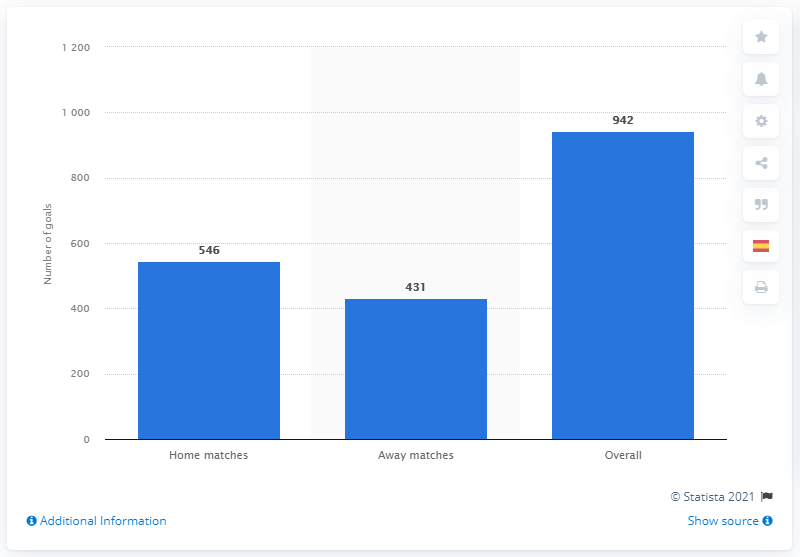Draw attention to some important aspects in this diagram. During the 2019/2020 season, a total of 431 goals were scored in home matches. In the 2019/2020 season, a total of 942 goals were scored. 